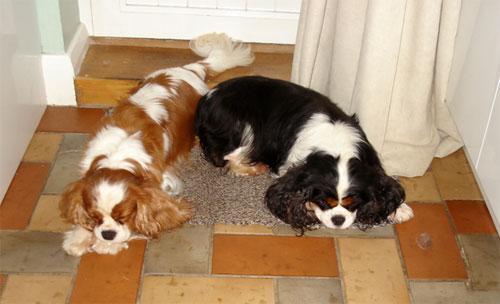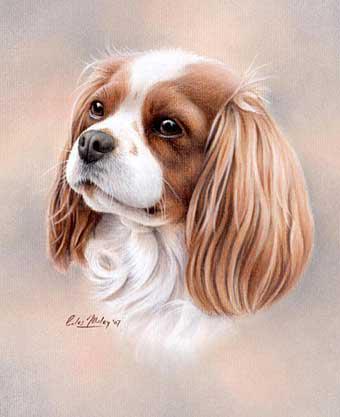The first image is the image on the left, the second image is the image on the right. Given the left and right images, does the statement "Each image depicts a single spaniel dog, and the dogs on the right and left have different fur coloring." hold true? Answer yes or no. No. The first image is the image on the left, the second image is the image on the right. Given the left and right images, does the statement "There are 2 dogs." hold true? Answer yes or no. No. 